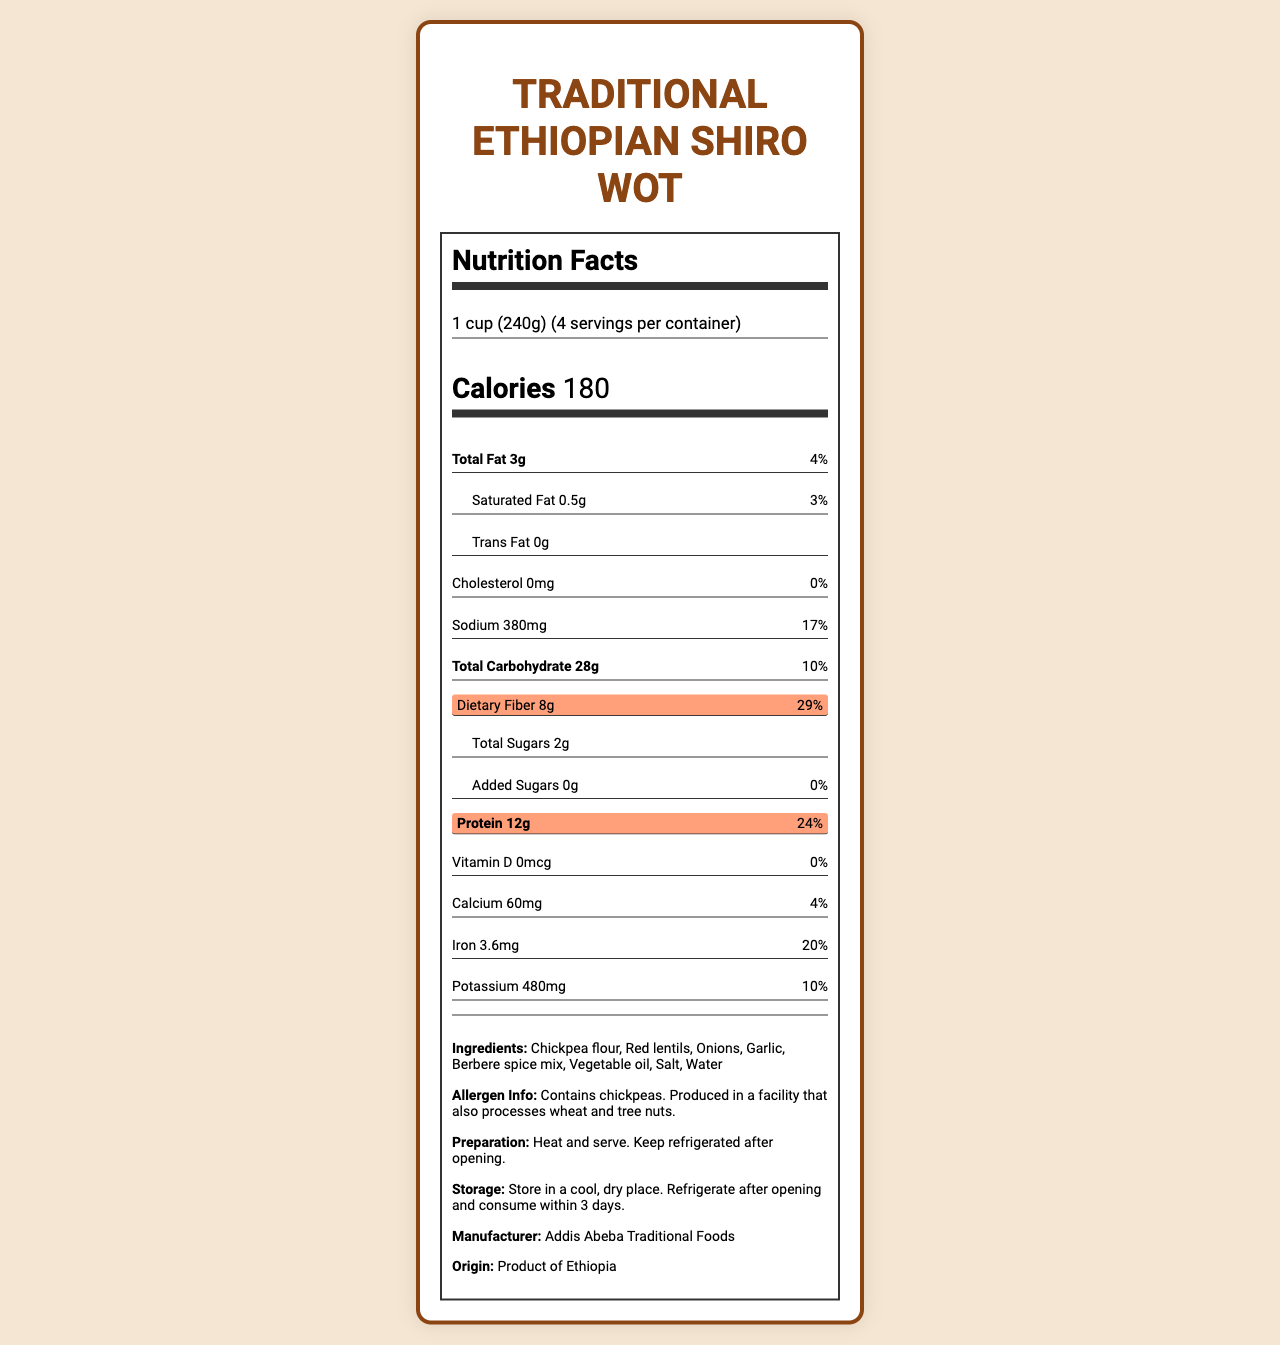Which product is the document about? The document title indicates that it's about Traditional Ethiopian Shiro Wot.
Answer: Traditional Ethiopian Shiro Wot What is the serving size? Under the "Nutrition Facts" heading, the serving size is specified as 1 cup (240g).
Answer: 1 cup (240g) How many servings are in one container? The label states that there are 4 servings per container.
Answer: 4 What is the amount of dietary fiber in one serving? The label specifies that one serving contains 8g of dietary fiber.
Answer: 8g What percentage of the daily value of protein does one serving provide? The nutrition label mentions that one serving contains 12g of protein, which is 24% of the daily value.
Answer: 24% How much total fat is there per serving? A. 1g B. 3g C. 5g D. 7g The label mentions a total fat content of 3g per serving.
Answer: B What percentage of the daily value of saturated fat is present in one serving? A. 1% B. 3% C. 5% D. 7% The label shows 0.5g of saturated fat, which is 3% of the daily value.
Answer: B Is there any cholesterol in this product? The label states that the cholesterol amount is 0mg, meaning no cholesterol is present.
Answer: No Summarize the main points of the document. The summary encapsulates the primary elements mentioned in the document, covering nutritional content and additional product details.
Answer: The document is a Nutrition Facts label for Traditional Ethiopian Shiro Wot. It describes the serving size, servings per container, and the nutritional content including calories, total fat, saturated fat, trans fat, cholesterol, sodium, total carbohydrate, dietary fiber, total sugars, added sugars, protein, vitamin D, calcium, iron, and potassium. Furthermore, it lists the ingredients, allergen information, preparation, and storage instructions, as well as the manufacturer's details and the product's origin. Can we determine the vitamin D source from this label? The document only lists the amount of vitamin D (0mcg) but does not provide information on its sources.
Answer: Not enough information What ingredient is likely responsible for the high protein content? Chickpea flour is listed as the first ingredient and is known for being high in protein, contributing to the 12g of protein per serving.
Answer: Chickpea flour 